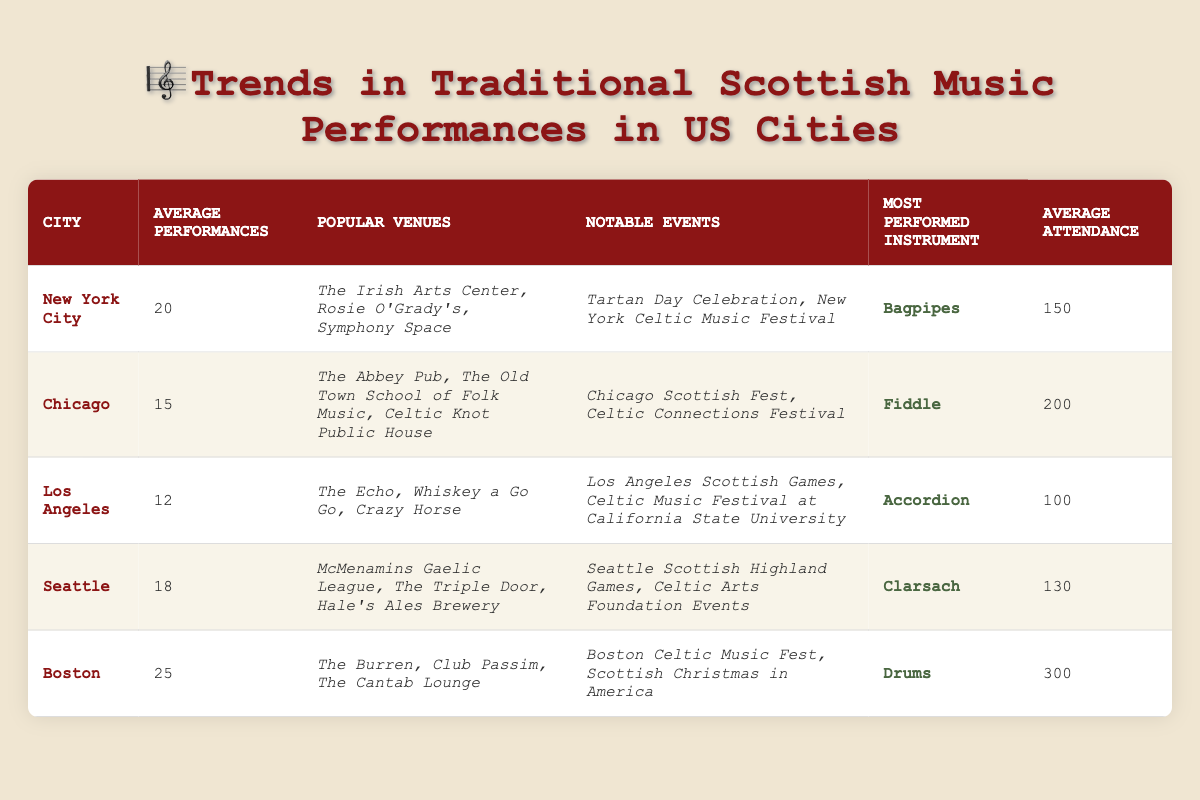What city has the highest average number of performances? Looking at the "Average Performances" column, Boston has the highest value at 25, while the other cities have lower averages (New York City has 20, Chicago 15, Los Angeles 12, and Seattle 18).
Answer: Boston Which instrument is most commonly performed in Chicago? The table shows that the most performed instrument in Chicago is the fiddle, as listed in the "Most Performed Instrument" column for the city.
Answer: Fiddle What is the average attendance in Los Angeles? The "Average Attendance" for Los Angeles is stated as 100 in the table, which directly answers the question.
Answer: 100 What notable events are held in New York City? In the "Notable Events" column for New York City, the events listed are the Tartan Day Celebration and the New York Celtic Music Festival.
Answer: Tartan Day Celebration, New York Celtic Music Festival Which city has the most average performances plus the lowest average attendance? Boston has the highest average performances (25), and Los Angeles has the lowest average attendance (100). Adding these gives 25 + 100 = 125.
Answer: 125 Is the average attendance in Seattle higher than in New York City? The average attendance in Seattle is 130, while in New York City it is 150. Since 130 is not greater than 150, the answer is no.
Answer: No What city has a notable event called "Scottish Christmas in America"? The event "Scottish Christmas in America" is mentioned in the "Notable Events" column for Boston, indicating that this city holds the event.
Answer: Boston How many more average performances does Boston have compared to Chicago? Boston has 25 average performances and Chicago has 15. The difference is 25 - 15 = 10.
Answer: 10 Which venue is popular in both New York City and Boston? By checking the "Popular Venues" column, none of the venues listed for New York City (The Irish Arts Center, Rosie O'Grady's, Symphony Space) appear in Boston (The Burren, Club Passim, The Cantab Lounge). Therefore, there are no common venues.
Answer: None What is the average number of performances across all listed cities? To find the average, I sum the average performances: 20 (NYC) + 15 (Chicago) + 12 (LA) + 18 (Seattle) + 25 (Boston) = 90. Then I divide by the number of cities (5): 90/5 = 18.
Answer: 18 